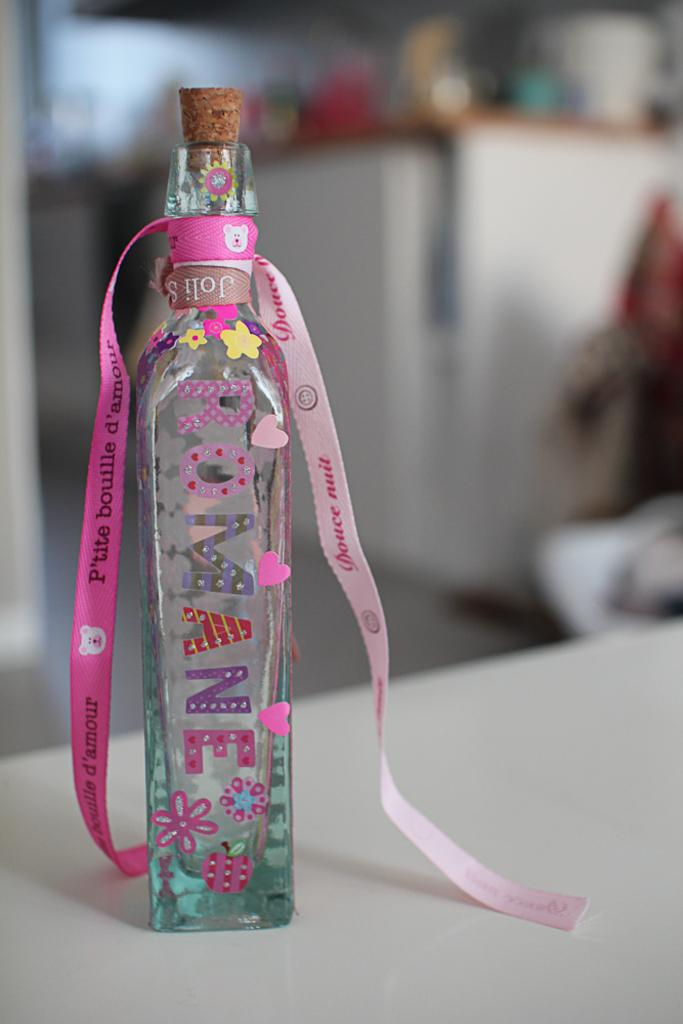What object is the main focus of the picture? There is a glass bottle in the picture. How is the bottle decorated? The bottle is decorated with a ribbon and stickers. What is the color of the table the bottle is on? The table is white. What color is the background of the image? The background of the image is blue due to the bottle being focused. What type of shirt is the alarm wearing in the image? There is no shirt or alarm present in the image; it features a glass bottle decorated with a ribbon and stickers on a white table with a blue background. 